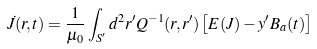Convert formula to latex. <formula><loc_0><loc_0><loc_500><loc_500>\dot { J } ( r , t ) = \frac { 1 } { \mu _ { 0 } } \int _ { S ^ { \prime } } d ^ { 2 } r ^ { \prime } Q ^ { - 1 } ( r , r ^ { \prime } ) \left [ E ( J ) - y ^ { \prime } B _ { a } ( t ) \right ]</formula> 